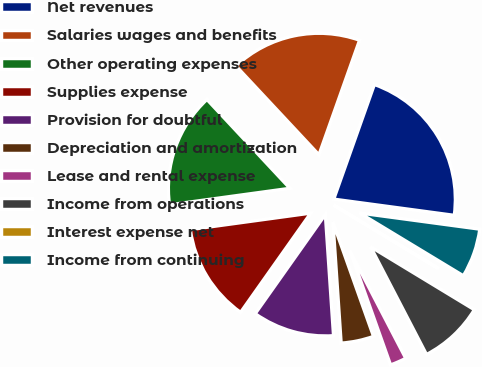Convert chart. <chart><loc_0><loc_0><loc_500><loc_500><pie_chart><fcel>Net revenues<fcel>Salaries wages and benefits<fcel>Other operating expenses<fcel>Supplies expense<fcel>Provision for doubtful<fcel>Depreciation and amortization<fcel>Lease and rental expense<fcel>Income from operations<fcel>Interest expense net<fcel>Income from continuing<nl><fcel>21.71%<fcel>17.38%<fcel>15.21%<fcel>13.04%<fcel>10.87%<fcel>4.36%<fcel>2.19%<fcel>8.7%<fcel>0.02%<fcel>6.53%<nl></chart> 